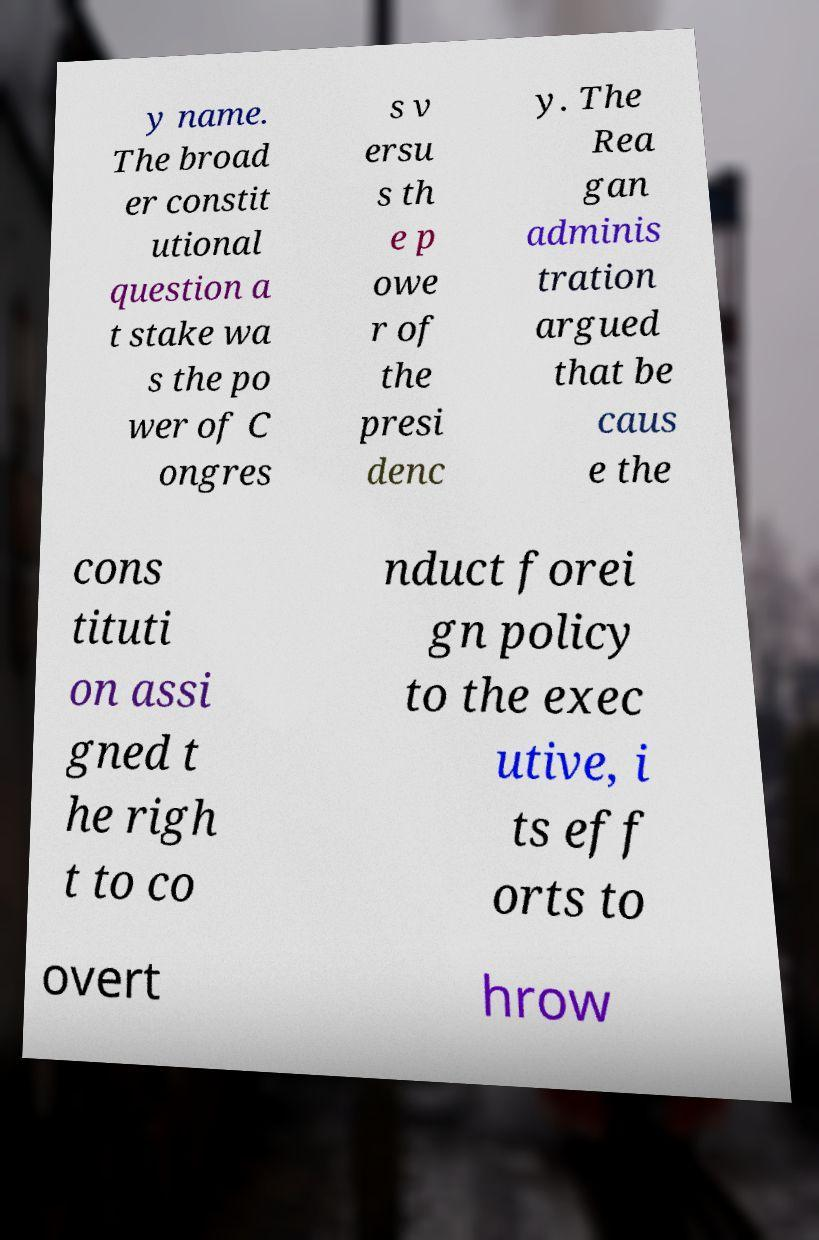What messages or text are displayed in this image? I need them in a readable, typed format. y name. The broad er constit utional question a t stake wa s the po wer of C ongres s v ersu s th e p owe r of the presi denc y. The Rea gan adminis tration argued that be caus e the cons tituti on assi gned t he righ t to co nduct forei gn policy to the exec utive, i ts eff orts to overt hrow 